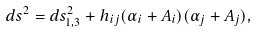<formula> <loc_0><loc_0><loc_500><loc_500>d s ^ { 2 } = d s _ { 1 , 3 } ^ { 2 } + h _ { i j } ( \alpha _ { i } + A _ { i } ) ( \alpha _ { j } + A _ { j } ) ,</formula> 